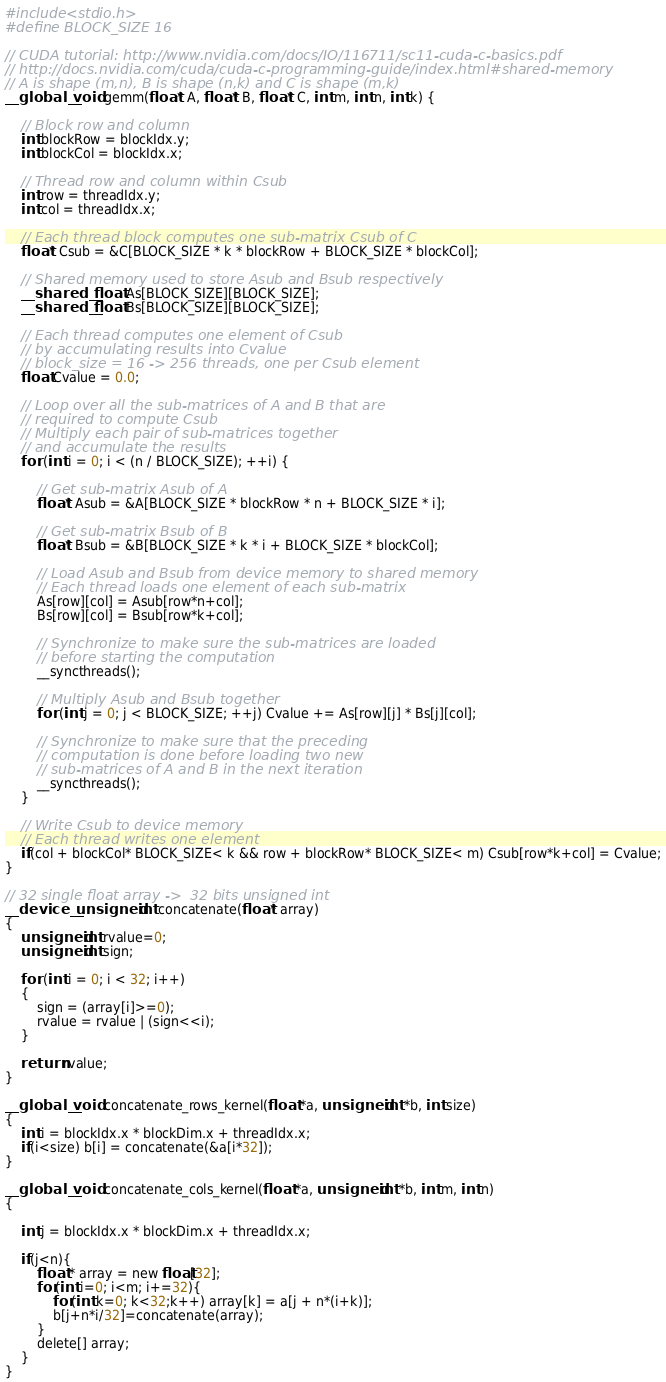Convert code to text. <code><loc_0><loc_0><loc_500><loc_500><_Cuda_>
#include <stdio.h>
#define BLOCK_SIZE 16

// CUDA tutorial: http://www.nvidia.com/docs/IO/116711/sc11-cuda-c-basics.pdf
// http://docs.nvidia.com/cuda/cuda-c-programming-guide/index.html#shared-memory
// A is shape (m,n), B is shape (n,k) and C is shape (m,k)
__global__ void gemm(float* A, float* B, float* C, int m, int n, int k) {

    // Block row and column
    int blockRow = blockIdx.y;
    int blockCol = blockIdx.x;
    
    // Thread row and column within Csub
    int row = threadIdx.y;
    int col = threadIdx.x;

    // Each thread block computes one sub-matrix Csub of C
    float* Csub = &C[BLOCK_SIZE * k * blockRow + BLOCK_SIZE * blockCol];

    // Shared memory used to store Asub and Bsub respectively
    __shared__ float As[BLOCK_SIZE][BLOCK_SIZE];
    __shared__ float Bs[BLOCK_SIZE][BLOCK_SIZE];
    
    // Each thread computes one element of Csub
    // by accumulating results into Cvalue
    // block_size = 16 -> 256 threads, one per Csub element
    float Cvalue = 0.0;
    
    // Loop over all the sub-matrices of A and B that are
    // required to compute Csub
    // Multiply each pair of sub-matrices together
    // and accumulate the results
    for (int i = 0; i < (n / BLOCK_SIZE); ++i) {
    
        // Get sub-matrix Asub of A
        float* Asub = &A[BLOCK_SIZE * blockRow * n + BLOCK_SIZE * i];
        
        // Get sub-matrix Bsub of B
        float* Bsub = &B[BLOCK_SIZE * k * i + BLOCK_SIZE * blockCol];
        
        // Load Asub and Bsub from device memory to shared memory
        // Each thread loads one element of each sub-matrix
        As[row][col] = Asub[row*n+col];
        Bs[row][col] = Bsub[row*k+col];
    
        // Synchronize to make sure the sub-matrices are loaded
        // before starting the computation
        __syncthreads();
        
        // Multiply Asub and Bsub together
        for (int j = 0; j < BLOCK_SIZE; ++j) Cvalue += As[row][j] * Bs[j][col]; 
        
        // Synchronize to make sure that the preceding
        // computation is done before loading two new
        // sub-matrices of A and B in the next iteration
        __syncthreads();
    }
    
    // Write Csub to device memory
    // Each thread writes one element
    if(col + blockCol* BLOCK_SIZE< k && row + blockRow* BLOCK_SIZE< m) Csub[row*k+col] = Cvalue;
}

// 32 single float array ->  32 bits unsigned int
__device__ unsigned int concatenate(float* array)
{
    unsigned int rvalue=0;
    unsigned int sign;
    
    for (int i = 0; i < 32; i++)
    {
        sign = (array[i]>=0);
        rvalue = rvalue | (sign<<i);
    }
    
    return rvalue;
}

__global__ void concatenate_rows_kernel(float *a, unsigned int *b, int size)
{ 
    int i = blockIdx.x * blockDim.x + threadIdx.x;
    if(i<size) b[i] = concatenate(&a[i*32]);
}

__global__ void concatenate_cols_kernel(float *a, unsigned int *b, int m, int n)
{   

    int j = blockIdx.x * blockDim.x + threadIdx.x;
    
    if(j<n){
        float * array = new float[32];
        for(int i=0; i<m; i+=32){
            for(int k=0; k<32;k++) array[k] = a[j + n*(i+k)];
            b[j+n*i/32]=concatenate(array); 
        } 
        delete[] array;
    }
}
</code> 